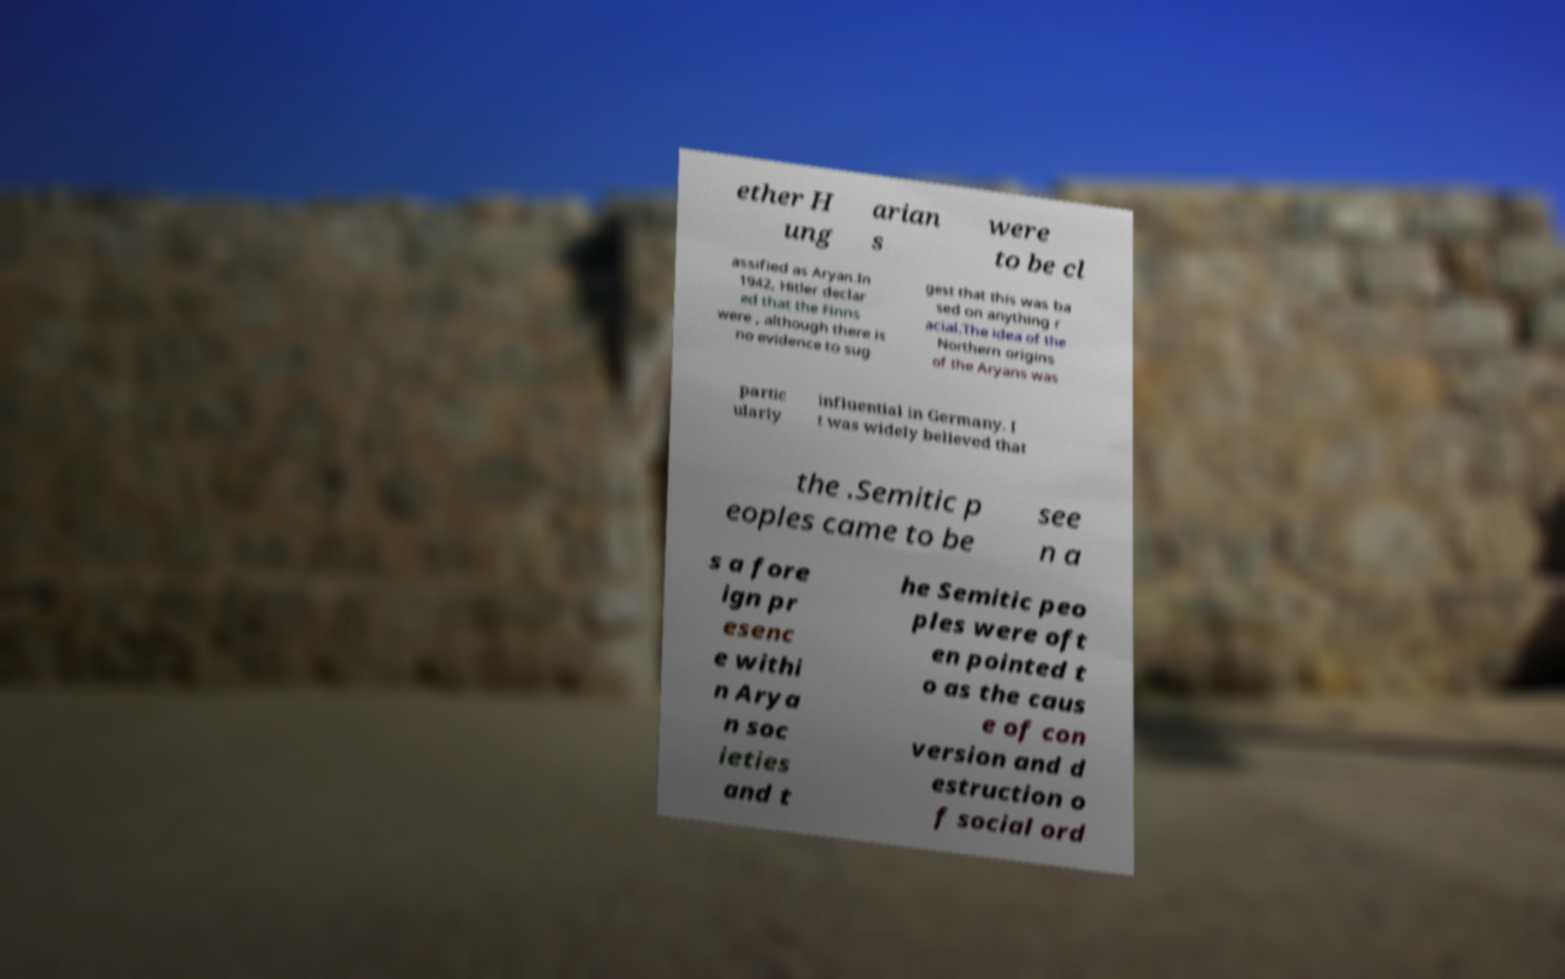Please identify and transcribe the text found in this image. ether H ung arian s were to be cl assified as Aryan.In 1942, Hitler declar ed that the Finns were , although there is no evidence to sug gest that this was ba sed on anything r acial.The idea of the Northern origins of the Aryans was partic ularly influential in Germany. I t was widely believed that the .Semitic p eoples came to be see n a s a fore ign pr esenc e withi n Arya n soc ieties and t he Semitic peo ples were oft en pointed t o as the caus e of con version and d estruction o f social ord 